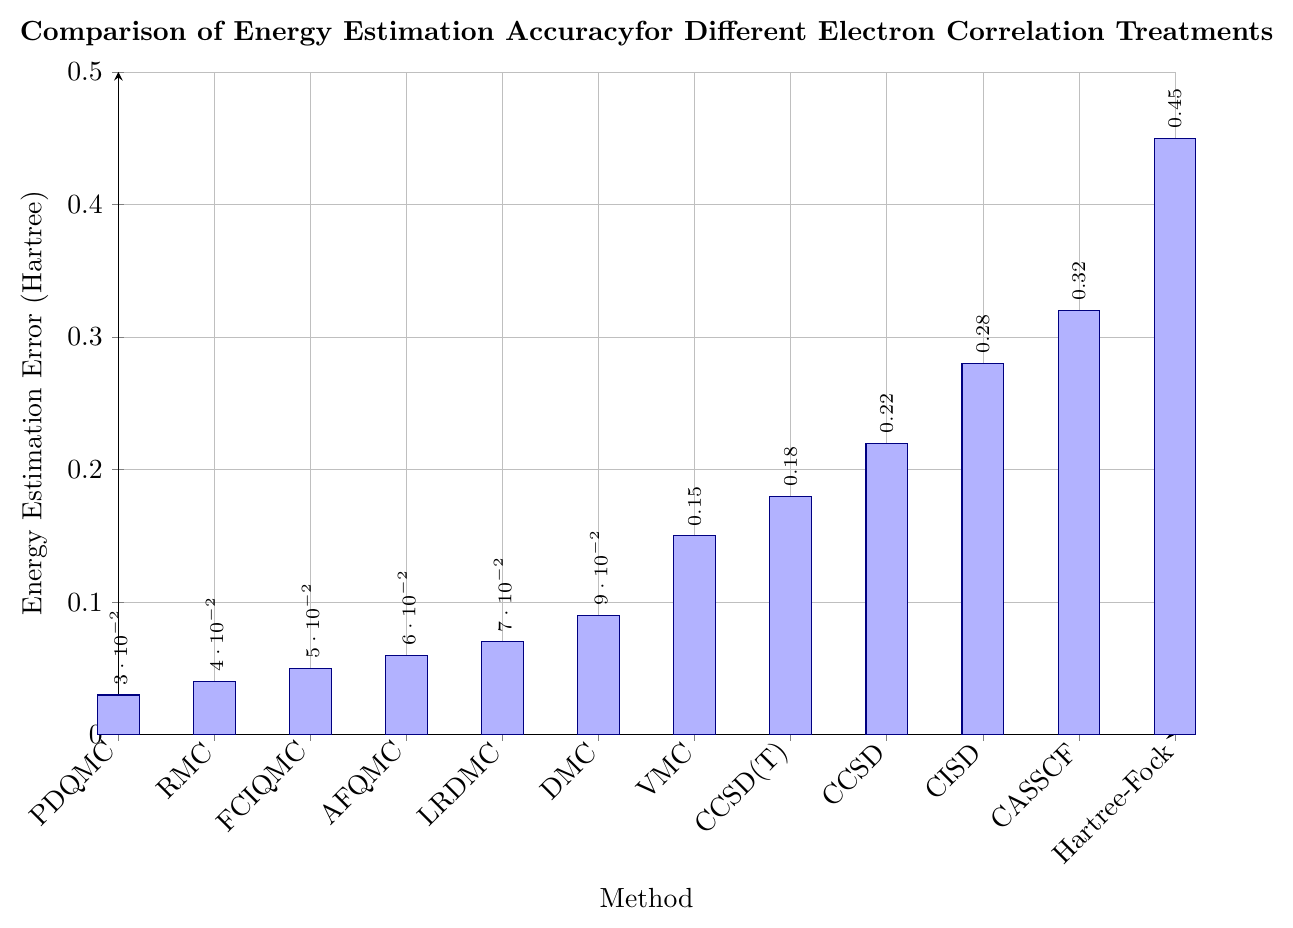How many methods have an energy estimation error less than 0.1 Hartree? First, identify the bars representing methods with errors less than 0.1 Hartree. These methods are PDQMC, RMC, FCIQMC, AFQMC, LRDMC, and DMC. Count them to get the total.
Answer: 6 Which method has the highest energy estimation error? Look for the tallest bar in the chart. The highest energy estimation error is associated with the Hartree-Fock method.
Answer: Hartree-Fock What is the difference in energy estimation error between DMC and VMC? Identify the energy estimation errors for DMC (0.09 Hartree) and VMC (0.15 Hartree). Subtract the smaller value from the larger value: 0.15 - 0.09 = 0.06.
Answer: 0.06 Between CCSD(T) and CCSD, which has a lower energy estimation error and by how much? Note the energy estimation errors for CCSD(T) (0.18 Hartree) and CCSD (0.22 Hartree). CCSD(T) has a lower error. Subtract CCSD(T) from CCSD: 0.22 - 0.18 = 0.04.
Answer: CCSD(T), 0.04 Rank the methods in ascending order of energy estimation error. List the methods and arrange them from the smallest error to the largest by reading the heights of the bars: PDQMC (0.03), RMC (0.04), FCIQMC (0.05), AFQMC (0.06), LRDMC (0.07), DMC (0.09), VMC (0.15), CCSD(T) (0.18), CCSD (0.22), CISD (0.28), CASSCF (0.32), Hartree-Fock (0.45).
Answer: PDQMC, RMC, FCIQMC, AFQMC, LRDMC, DMC, VMC, CCSD(T), CCSD, CISD, CASSCF, Hartree-Fock What is the median energy estimation error among all methods? First, list the energy estimation errors in ascending order: 0.03, 0.04, 0.05, 0.06, 0.07, 0.09, 0.15, 0.18, 0.22, 0.28, 0.32, 0.45. Since there are 12 data points, the median is the average of the 6th and 7th values: (0.09 + 0.15) / 2 = 0.12.
Answer: 0.12 What is the average energy estimation error for CASSCF, Hartree-Fock, and CISD? Add the errors for CASSCF (0.32 Hartree), Hartree-Fock (0.45 Hartree), and CISD (0.28 Hartree), then divide by 3: (0.32 + 0.45 + 0.28) / 3 = 1.05 / 3 = 0.35.
Answer: 0.35 